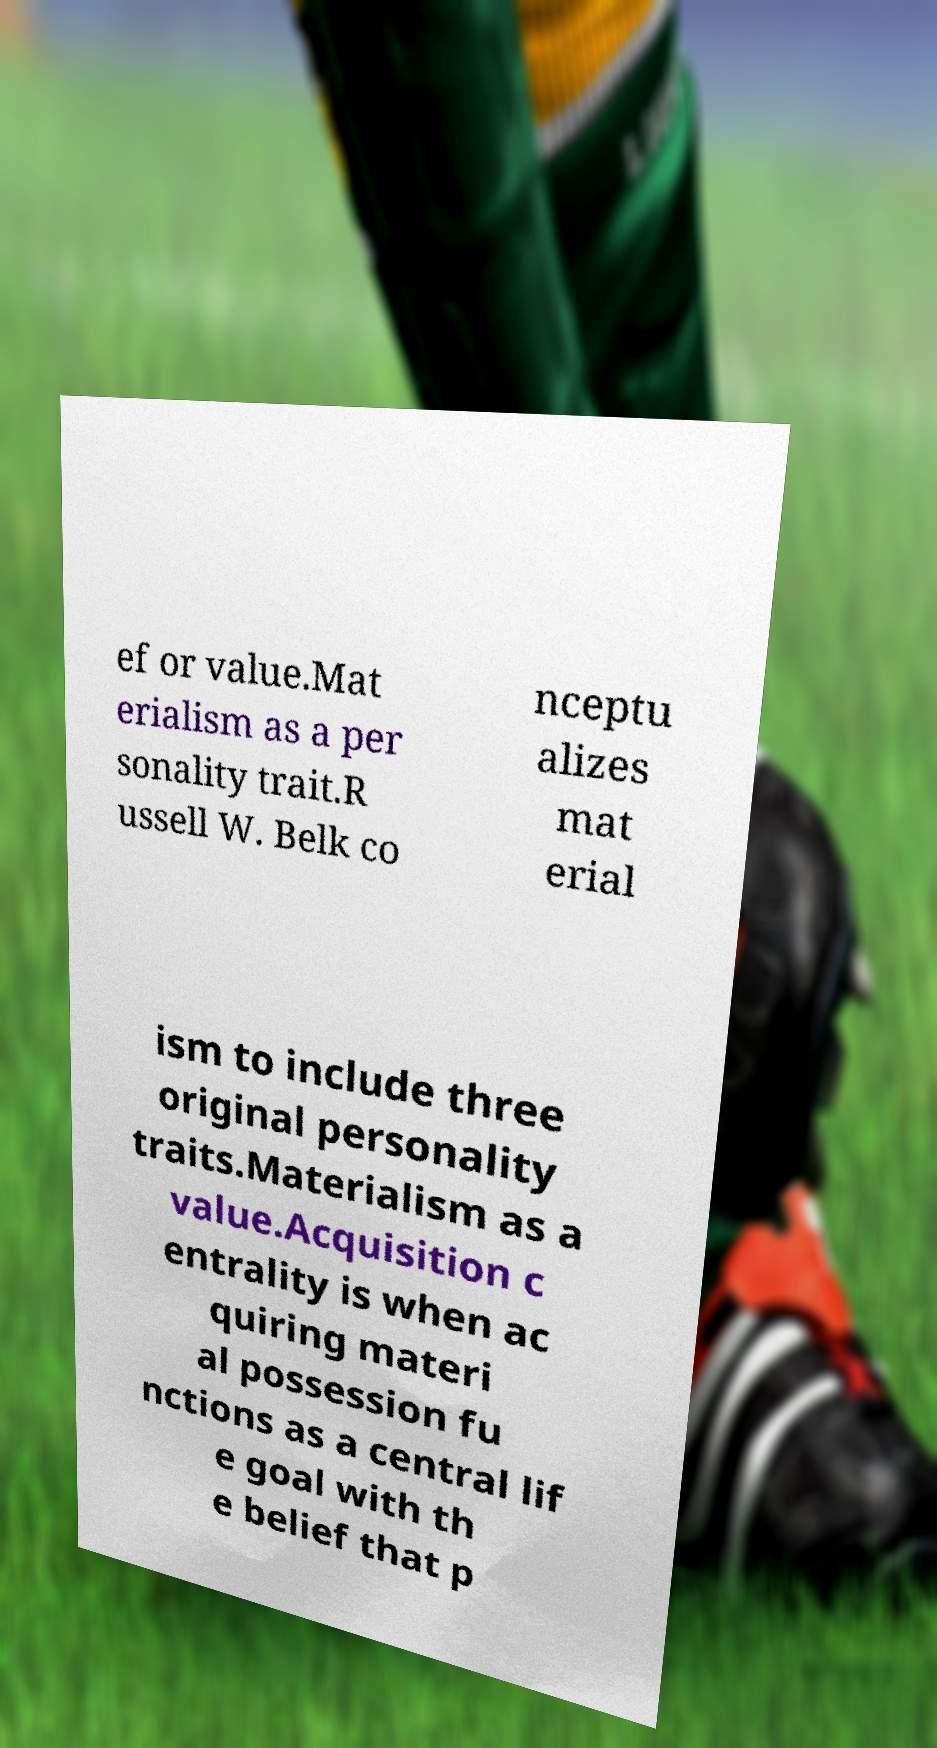Could you assist in decoding the text presented in this image and type it out clearly? ef or value.Mat erialism as a per sonality trait.R ussell W. Belk co nceptu alizes mat erial ism to include three original personality traits.Materialism as a value.Acquisition c entrality is when ac quiring materi al possession fu nctions as a central lif e goal with th e belief that p 